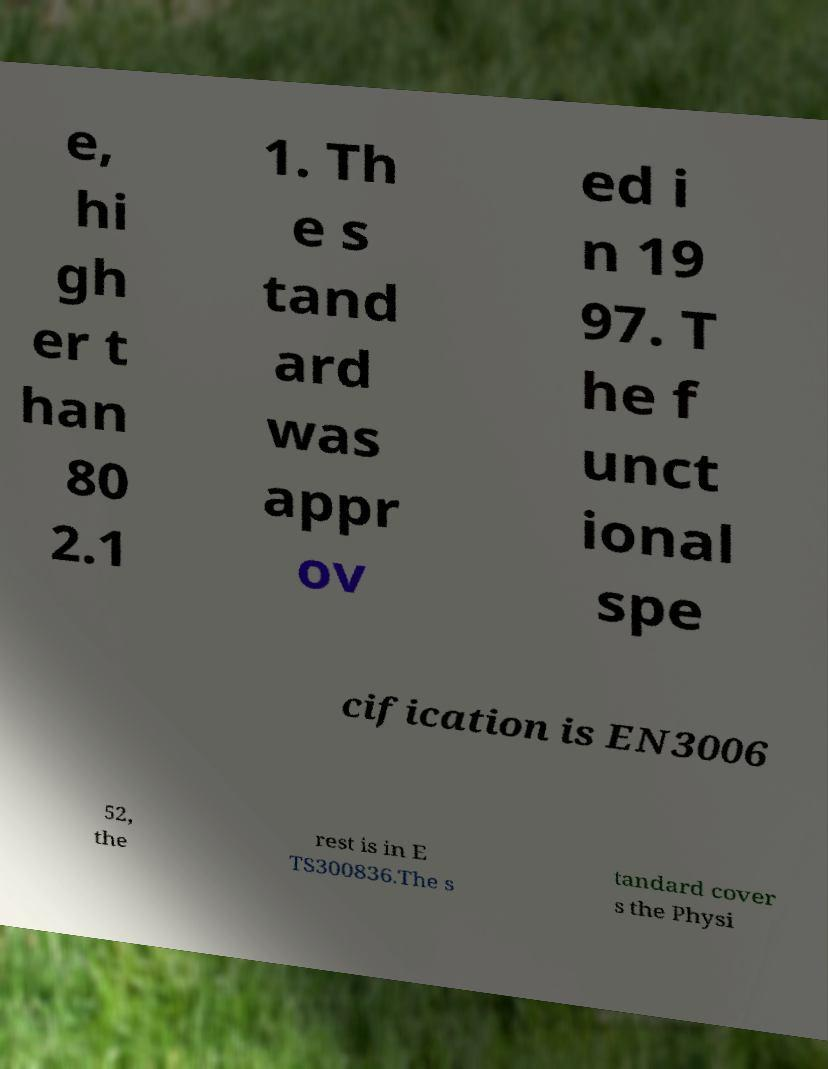Can you accurately transcribe the text from the provided image for me? e, hi gh er t han 80 2.1 1. Th e s tand ard was appr ov ed i n 19 97. T he f unct ional spe cification is EN3006 52, the rest is in E TS300836.The s tandard cover s the Physi 